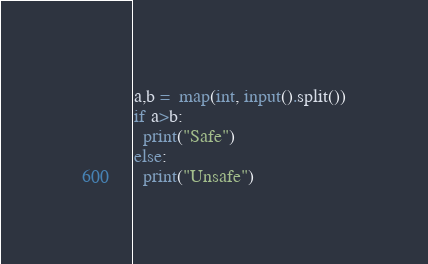<code> <loc_0><loc_0><loc_500><loc_500><_Python_>a,b =  map(int, input().split())
if a>b:
  print("Safe")
else:
  print("Unsafe")</code> 